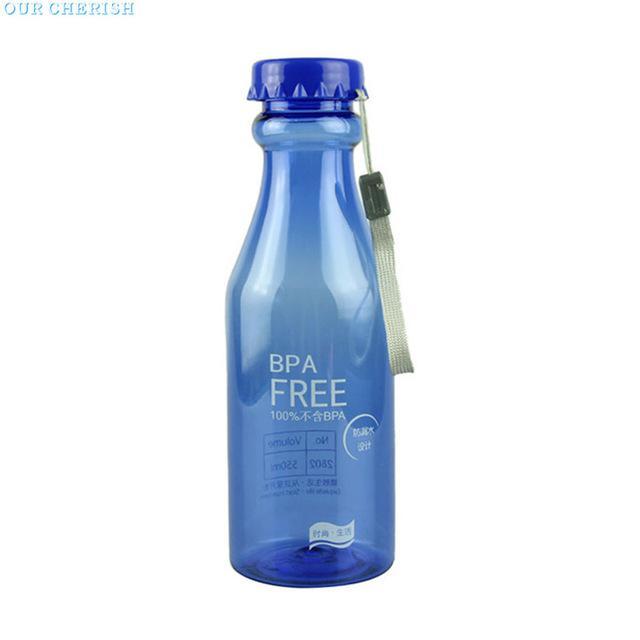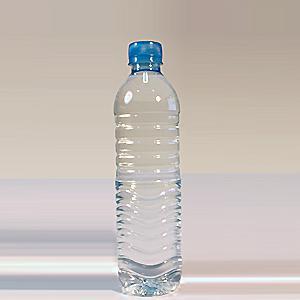The first image is the image on the left, the second image is the image on the right. Considering the images on both sides, is "The bottle caps are all blue." valid? Answer yes or no. Yes. The first image is the image on the left, the second image is the image on the right. Examine the images to the left and right. Is the description "There is a reusable water bottle on the left and a disposable bottle on the right." accurate? Answer yes or no. Yes. 